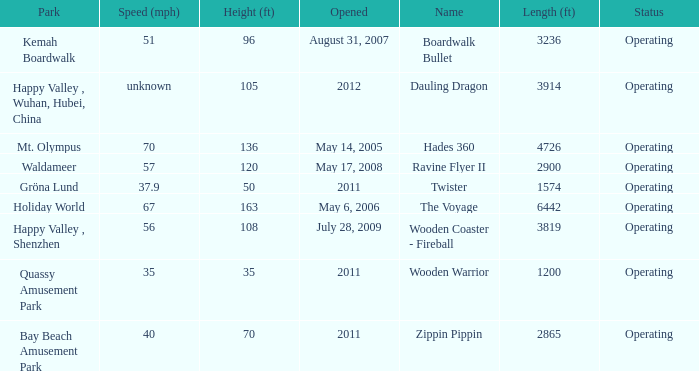How many parks is Zippin Pippin located in 1.0. 